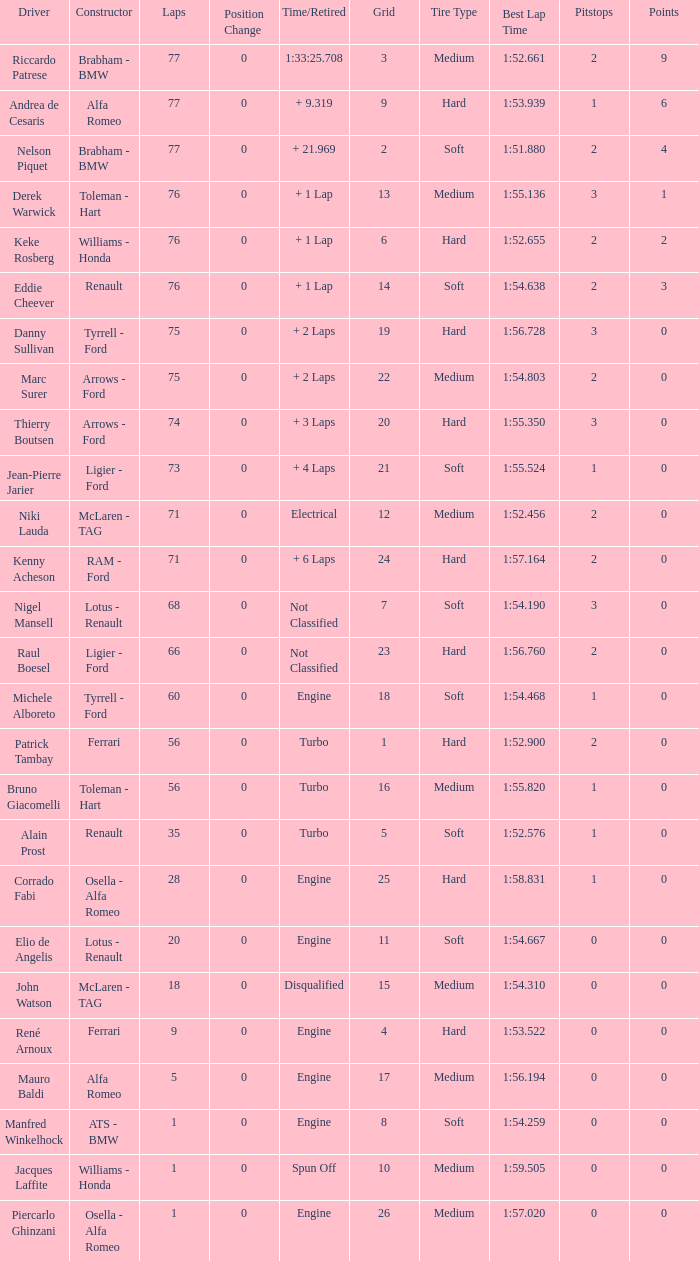Who drove the grid 10 car? Jacques Laffite. 